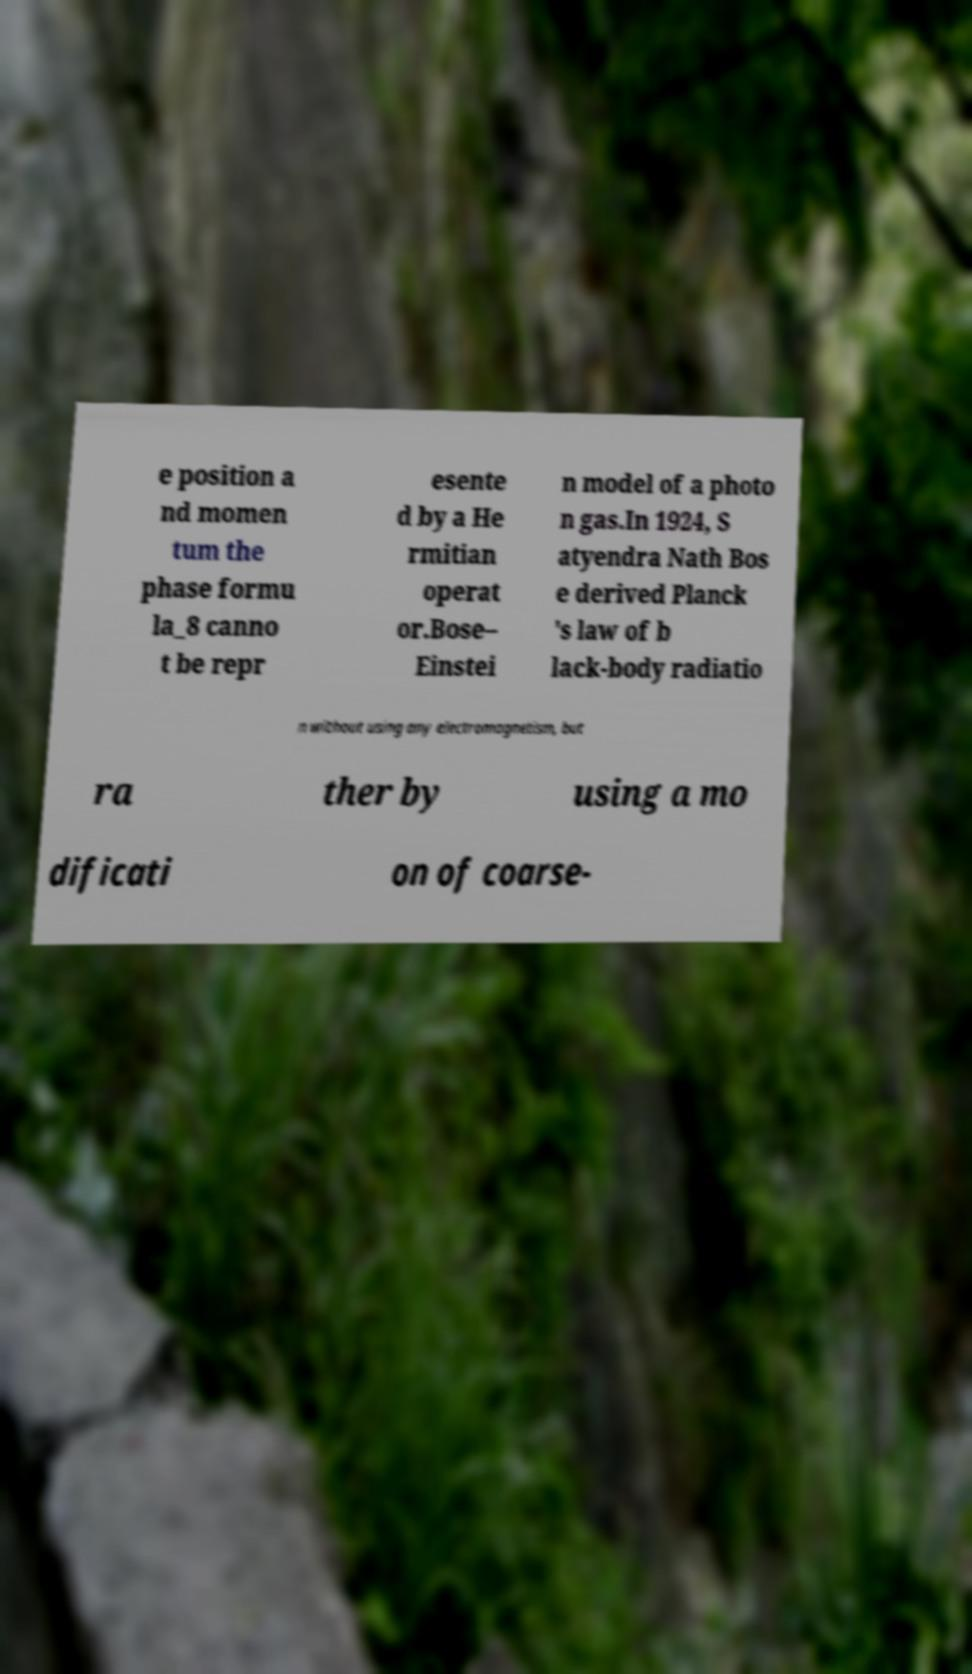Could you extract and type out the text from this image? e position a nd momen tum the phase formu la_8 canno t be repr esente d by a He rmitian operat or.Bose– Einstei n model of a photo n gas.In 1924, S atyendra Nath Bos e derived Planck 's law of b lack-body radiatio n without using any electromagnetism, but ra ther by using a mo dificati on of coarse- 